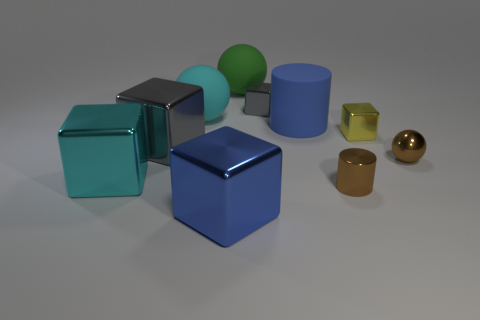Does the tiny ball have the same color as the shiny cylinder?
Your response must be concise. Yes. What number of big brown matte cubes are there?
Offer a very short reply. 0. What shape is the small thing that is in front of the yellow metallic block and to the left of the small brown ball?
Offer a terse response. Cylinder. There is a blue object that is behind the gray metallic thing in front of the blue object that is behind the small ball; what shape is it?
Your answer should be compact. Cylinder. What material is the block that is both in front of the big cyan matte object and on the right side of the big green rubber ball?
Provide a succinct answer. Metal. What number of red cylinders are the same size as the cyan metallic object?
Provide a short and direct response. 0. How many matte objects are big cylinders or big green things?
Keep it short and to the point. 2. What is the small yellow thing made of?
Your answer should be compact. Metal. There is a tiny yellow thing; what number of yellow cubes are behind it?
Give a very brief answer. 0. Is the cube that is on the left side of the big gray shiny thing made of the same material as the blue cylinder?
Give a very brief answer. No. 